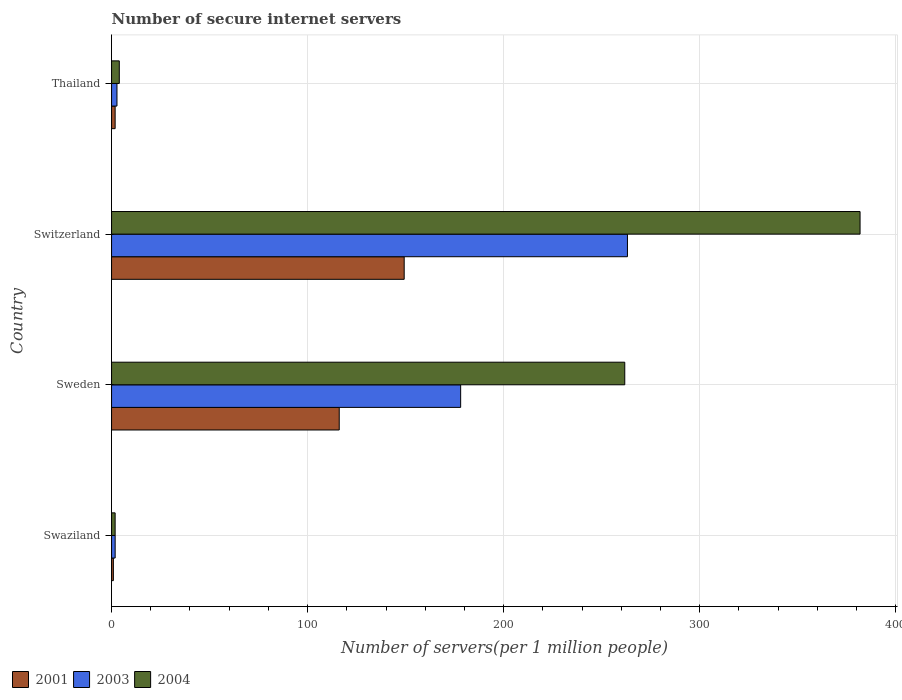How many bars are there on the 2nd tick from the top?
Ensure brevity in your answer.  3. How many bars are there on the 2nd tick from the bottom?
Provide a succinct answer. 3. What is the number of secure internet servers in 2004 in Thailand?
Offer a very short reply. 3.94. Across all countries, what is the maximum number of secure internet servers in 2003?
Your response must be concise. 263.11. Across all countries, what is the minimum number of secure internet servers in 2001?
Your response must be concise. 0.93. In which country was the number of secure internet servers in 2003 maximum?
Offer a terse response. Switzerland. In which country was the number of secure internet servers in 2003 minimum?
Keep it short and to the point. Swaziland. What is the total number of secure internet servers in 2003 in the graph?
Ensure brevity in your answer.  445.76. What is the difference between the number of secure internet servers in 2004 in Switzerland and that in Thailand?
Your answer should be very brief. 377.81. What is the difference between the number of secure internet servers in 2004 in Thailand and the number of secure internet servers in 2003 in Switzerland?
Ensure brevity in your answer.  -259.17. What is the average number of secure internet servers in 2003 per country?
Offer a very short reply. 111.44. What is the difference between the number of secure internet servers in 2003 and number of secure internet servers in 2001 in Thailand?
Offer a very short reply. 0.93. In how many countries, is the number of secure internet servers in 2004 greater than 40 ?
Your response must be concise. 2. What is the ratio of the number of secure internet servers in 2004 in Sweden to that in Thailand?
Make the answer very short. 66.35. Is the number of secure internet servers in 2003 in Sweden less than that in Thailand?
Your answer should be compact. No. Is the difference between the number of secure internet servers in 2003 in Swaziland and Thailand greater than the difference between the number of secure internet servers in 2001 in Swaziland and Thailand?
Give a very brief answer. No. What is the difference between the highest and the second highest number of secure internet servers in 2001?
Give a very brief answer. 33.12. What is the difference between the highest and the lowest number of secure internet servers in 2003?
Your answer should be compact. 261.28. In how many countries, is the number of secure internet servers in 2001 greater than the average number of secure internet servers in 2001 taken over all countries?
Offer a terse response. 2. What does the 2nd bar from the bottom in Sweden represents?
Your answer should be compact. 2003. Is it the case that in every country, the sum of the number of secure internet servers in 2003 and number of secure internet servers in 2004 is greater than the number of secure internet servers in 2001?
Your answer should be very brief. Yes. How many bars are there?
Give a very brief answer. 12. Are all the bars in the graph horizontal?
Your response must be concise. Yes. How many countries are there in the graph?
Keep it short and to the point. 4. What is the difference between two consecutive major ticks on the X-axis?
Keep it short and to the point. 100. Where does the legend appear in the graph?
Give a very brief answer. Bottom left. How many legend labels are there?
Your answer should be very brief. 3. What is the title of the graph?
Provide a succinct answer. Number of secure internet servers. Does "1982" appear as one of the legend labels in the graph?
Keep it short and to the point. No. What is the label or title of the X-axis?
Offer a terse response. Number of servers(per 1 million people). What is the label or title of the Y-axis?
Keep it short and to the point. Country. What is the Number of servers(per 1 million people) in 2001 in Swaziland?
Offer a terse response. 0.93. What is the Number of servers(per 1 million people) of 2003 in Swaziland?
Offer a very short reply. 1.84. What is the Number of servers(per 1 million people) in 2004 in Swaziland?
Offer a terse response. 1.83. What is the Number of servers(per 1 million people) of 2001 in Sweden?
Your answer should be compact. 116.12. What is the Number of servers(per 1 million people) of 2003 in Sweden?
Provide a succinct answer. 178.05. What is the Number of servers(per 1 million people) of 2004 in Sweden?
Keep it short and to the point. 261.74. What is the Number of servers(per 1 million people) in 2001 in Switzerland?
Your answer should be very brief. 149.24. What is the Number of servers(per 1 million people) in 2003 in Switzerland?
Your answer should be compact. 263.11. What is the Number of servers(per 1 million people) in 2004 in Switzerland?
Give a very brief answer. 381.75. What is the Number of servers(per 1 million people) in 2001 in Thailand?
Ensure brevity in your answer.  1.83. What is the Number of servers(per 1 million people) of 2003 in Thailand?
Ensure brevity in your answer.  2.76. What is the Number of servers(per 1 million people) of 2004 in Thailand?
Offer a terse response. 3.94. Across all countries, what is the maximum Number of servers(per 1 million people) in 2001?
Provide a succinct answer. 149.24. Across all countries, what is the maximum Number of servers(per 1 million people) of 2003?
Your response must be concise. 263.11. Across all countries, what is the maximum Number of servers(per 1 million people) in 2004?
Offer a terse response. 381.75. Across all countries, what is the minimum Number of servers(per 1 million people) of 2001?
Keep it short and to the point. 0.93. Across all countries, what is the minimum Number of servers(per 1 million people) of 2003?
Provide a short and direct response. 1.84. Across all countries, what is the minimum Number of servers(per 1 million people) in 2004?
Your answer should be very brief. 1.83. What is the total Number of servers(per 1 million people) in 2001 in the graph?
Keep it short and to the point. 268.12. What is the total Number of servers(per 1 million people) in 2003 in the graph?
Keep it short and to the point. 445.76. What is the total Number of servers(per 1 million people) in 2004 in the graph?
Offer a very short reply. 649.27. What is the difference between the Number of servers(per 1 million people) in 2001 in Swaziland and that in Sweden?
Give a very brief answer. -115.19. What is the difference between the Number of servers(per 1 million people) in 2003 in Swaziland and that in Sweden?
Provide a succinct answer. -176.21. What is the difference between the Number of servers(per 1 million people) in 2004 in Swaziland and that in Sweden?
Provide a short and direct response. -259.92. What is the difference between the Number of servers(per 1 million people) in 2001 in Swaziland and that in Switzerland?
Make the answer very short. -148.31. What is the difference between the Number of servers(per 1 million people) of 2003 in Swaziland and that in Switzerland?
Give a very brief answer. -261.28. What is the difference between the Number of servers(per 1 million people) of 2004 in Swaziland and that in Switzerland?
Provide a succinct answer. -379.92. What is the difference between the Number of servers(per 1 million people) in 2001 in Swaziland and that in Thailand?
Give a very brief answer. -0.9. What is the difference between the Number of servers(per 1 million people) of 2003 in Swaziland and that in Thailand?
Make the answer very short. -0.92. What is the difference between the Number of servers(per 1 million people) of 2004 in Swaziland and that in Thailand?
Give a very brief answer. -2.12. What is the difference between the Number of servers(per 1 million people) of 2001 in Sweden and that in Switzerland?
Your answer should be very brief. -33.12. What is the difference between the Number of servers(per 1 million people) of 2003 in Sweden and that in Switzerland?
Your response must be concise. -85.07. What is the difference between the Number of servers(per 1 million people) in 2004 in Sweden and that in Switzerland?
Provide a succinct answer. -120.01. What is the difference between the Number of servers(per 1 million people) in 2001 in Sweden and that in Thailand?
Ensure brevity in your answer.  114.29. What is the difference between the Number of servers(per 1 million people) of 2003 in Sweden and that in Thailand?
Offer a terse response. 175.29. What is the difference between the Number of servers(per 1 million people) in 2004 in Sweden and that in Thailand?
Provide a succinct answer. 257.8. What is the difference between the Number of servers(per 1 million people) in 2001 in Switzerland and that in Thailand?
Offer a terse response. 147.41. What is the difference between the Number of servers(per 1 million people) of 2003 in Switzerland and that in Thailand?
Ensure brevity in your answer.  260.35. What is the difference between the Number of servers(per 1 million people) of 2004 in Switzerland and that in Thailand?
Make the answer very short. 377.81. What is the difference between the Number of servers(per 1 million people) in 2001 in Swaziland and the Number of servers(per 1 million people) in 2003 in Sweden?
Give a very brief answer. -177.12. What is the difference between the Number of servers(per 1 million people) of 2001 in Swaziland and the Number of servers(per 1 million people) of 2004 in Sweden?
Provide a succinct answer. -260.81. What is the difference between the Number of servers(per 1 million people) in 2003 in Swaziland and the Number of servers(per 1 million people) in 2004 in Sweden?
Keep it short and to the point. -259.91. What is the difference between the Number of servers(per 1 million people) in 2001 in Swaziland and the Number of servers(per 1 million people) in 2003 in Switzerland?
Your answer should be compact. -262.18. What is the difference between the Number of servers(per 1 million people) in 2001 in Swaziland and the Number of servers(per 1 million people) in 2004 in Switzerland?
Ensure brevity in your answer.  -380.82. What is the difference between the Number of servers(per 1 million people) in 2003 in Swaziland and the Number of servers(per 1 million people) in 2004 in Switzerland?
Your answer should be very brief. -379.91. What is the difference between the Number of servers(per 1 million people) in 2001 in Swaziland and the Number of servers(per 1 million people) in 2003 in Thailand?
Your response must be concise. -1.83. What is the difference between the Number of servers(per 1 million people) in 2001 in Swaziland and the Number of servers(per 1 million people) in 2004 in Thailand?
Provide a succinct answer. -3.01. What is the difference between the Number of servers(per 1 million people) in 2003 in Swaziland and the Number of servers(per 1 million people) in 2004 in Thailand?
Ensure brevity in your answer.  -2.11. What is the difference between the Number of servers(per 1 million people) in 2001 in Sweden and the Number of servers(per 1 million people) in 2003 in Switzerland?
Give a very brief answer. -146.99. What is the difference between the Number of servers(per 1 million people) in 2001 in Sweden and the Number of servers(per 1 million people) in 2004 in Switzerland?
Offer a terse response. -265.63. What is the difference between the Number of servers(per 1 million people) in 2003 in Sweden and the Number of servers(per 1 million people) in 2004 in Switzerland?
Your answer should be compact. -203.7. What is the difference between the Number of servers(per 1 million people) in 2001 in Sweden and the Number of servers(per 1 million people) in 2003 in Thailand?
Offer a terse response. 113.36. What is the difference between the Number of servers(per 1 million people) in 2001 in Sweden and the Number of servers(per 1 million people) in 2004 in Thailand?
Make the answer very short. 112.18. What is the difference between the Number of servers(per 1 million people) in 2003 in Sweden and the Number of servers(per 1 million people) in 2004 in Thailand?
Provide a short and direct response. 174.1. What is the difference between the Number of servers(per 1 million people) in 2001 in Switzerland and the Number of servers(per 1 million people) in 2003 in Thailand?
Your response must be concise. 146.48. What is the difference between the Number of servers(per 1 million people) in 2001 in Switzerland and the Number of servers(per 1 million people) in 2004 in Thailand?
Keep it short and to the point. 145.3. What is the difference between the Number of servers(per 1 million people) in 2003 in Switzerland and the Number of servers(per 1 million people) in 2004 in Thailand?
Your answer should be compact. 259.17. What is the average Number of servers(per 1 million people) in 2001 per country?
Offer a very short reply. 67.03. What is the average Number of servers(per 1 million people) in 2003 per country?
Your response must be concise. 111.44. What is the average Number of servers(per 1 million people) in 2004 per country?
Provide a short and direct response. 162.32. What is the difference between the Number of servers(per 1 million people) in 2001 and Number of servers(per 1 million people) in 2003 in Swaziland?
Ensure brevity in your answer.  -0.91. What is the difference between the Number of servers(per 1 million people) in 2001 and Number of servers(per 1 million people) in 2004 in Swaziland?
Your response must be concise. -0.9. What is the difference between the Number of servers(per 1 million people) in 2003 and Number of servers(per 1 million people) in 2004 in Swaziland?
Keep it short and to the point. 0.01. What is the difference between the Number of servers(per 1 million people) of 2001 and Number of servers(per 1 million people) of 2003 in Sweden?
Offer a terse response. -61.93. What is the difference between the Number of servers(per 1 million people) of 2001 and Number of servers(per 1 million people) of 2004 in Sweden?
Offer a very short reply. -145.62. What is the difference between the Number of servers(per 1 million people) in 2003 and Number of servers(per 1 million people) in 2004 in Sweden?
Provide a succinct answer. -83.7. What is the difference between the Number of servers(per 1 million people) of 2001 and Number of servers(per 1 million people) of 2003 in Switzerland?
Your answer should be compact. -113.87. What is the difference between the Number of servers(per 1 million people) of 2001 and Number of servers(per 1 million people) of 2004 in Switzerland?
Provide a succinct answer. -232.51. What is the difference between the Number of servers(per 1 million people) in 2003 and Number of servers(per 1 million people) in 2004 in Switzerland?
Offer a very short reply. -118.64. What is the difference between the Number of servers(per 1 million people) of 2001 and Number of servers(per 1 million people) of 2003 in Thailand?
Your answer should be compact. -0.93. What is the difference between the Number of servers(per 1 million people) in 2001 and Number of servers(per 1 million people) in 2004 in Thailand?
Ensure brevity in your answer.  -2.12. What is the difference between the Number of servers(per 1 million people) of 2003 and Number of servers(per 1 million people) of 2004 in Thailand?
Your answer should be very brief. -1.18. What is the ratio of the Number of servers(per 1 million people) of 2001 in Swaziland to that in Sweden?
Provide a short and direct response. 0.01. What is the ratio of the Number of servers(per 1 million people) in 2003 in Swaziland to that in Sweden?
Make the answer very short. 0.01. What is the ratio of the Number of servers(per 1 million people) in 2004 in Swaziland to that in Sweden?
Your answer should be very brief. 0.01. What is the ratio of the Number of servers(per 1 million people) of 2001 in Swaziland to that in Switzerland?
Give a very brief answer. 0.01. What is the ratio of the Number of servers(per 1 million people) of 2003 in Swaziland to that in Switzerland?
Offer a very short reply. 0.01. What is the ratio of the Number of servers(per 1 million people) of 2004 in Swaziland to that in Switzerland?
Your response must be concise. 0. What is the ratio of the Number of servers(per 1 million people) in 2001 in Swaziland to that in Thailand?
Provide a succinct answer. 0.51. What is the ratio of the Number of servers(per 1 million people) of 2003 in Swaziland to that in Thailand?
Your response must be concise. 0.67. What is the ratio of the Number of servers(per 1 million people) of 2004 in Swaziland to that in Thailand?
Your response must be concise. 0.46. What is the ratio of the Number of servers(per 1 million people) in 2001 in Sweden to that in Switzerland?
Provide a short and direct response. 0.78. What is the ratio of the Number of servers(per 1 million people) of 2003 in Sweden to that in Switzerland?
Provide a short and direct response. 0.68. What is the ratio of the Number of servers(per 1 million people) in 2004 in Sweden to that in Switzerland?
Your response must be concise. 0.69. What is the ratio of the Number of servers(per 1 million people) of 2001 in Sweden to that in Thailand?
Your response must be concise. 63.48. What is the ratio of the Number of servers(per 1 million people) in 2003 in Sweden to that in Thailand?
Keep it short and to the point. 64.47. What is the ratio of the Number of servers(per 1 million people) of 2004 in Sweden to that in Thailand?
Make the answer very short. 66.35. What is the ratio of the Number of servers(per 1 million people) of 2001 in Switzerland to that in Thailand?
Your answer should be very brief. 81.59. What is the ratio of the Number of servers(per 1 million people) in 2003 in Switzerland to that in Thailand?
Your response must be concise. 95.28. What is the ratio of the Number of servers(per 1 million people) of 2004 in Switzerland to that in Thailand?
Offer a terse response. 96.78. What is the difference between the highest and the second highest Number of servers(per 1 million people) of 2001?
Offer a terse response. 33.12. What is the difference between the highest and the second highest Number of servers(per 1 million people) of 2003?
Provide a short and direct response. 85.07. What is the difference between the highest and the second highest Number of servers(per 1 million people) of 2004?
Make the answer very short. 120.01. What is the difference between the highest and the lowest Number of servers(per 1 million people) of 2001?
Your answer should be very brief. 148.31. What is the difference between the highest and the lowest Number of servers(per 1 million people) in 2003?
Offer a very short reply. 261.28. What is the difference between the highest and the lowest Number of servers(per 1 million people) in 2004?
Make the answer very short. 379.92. 